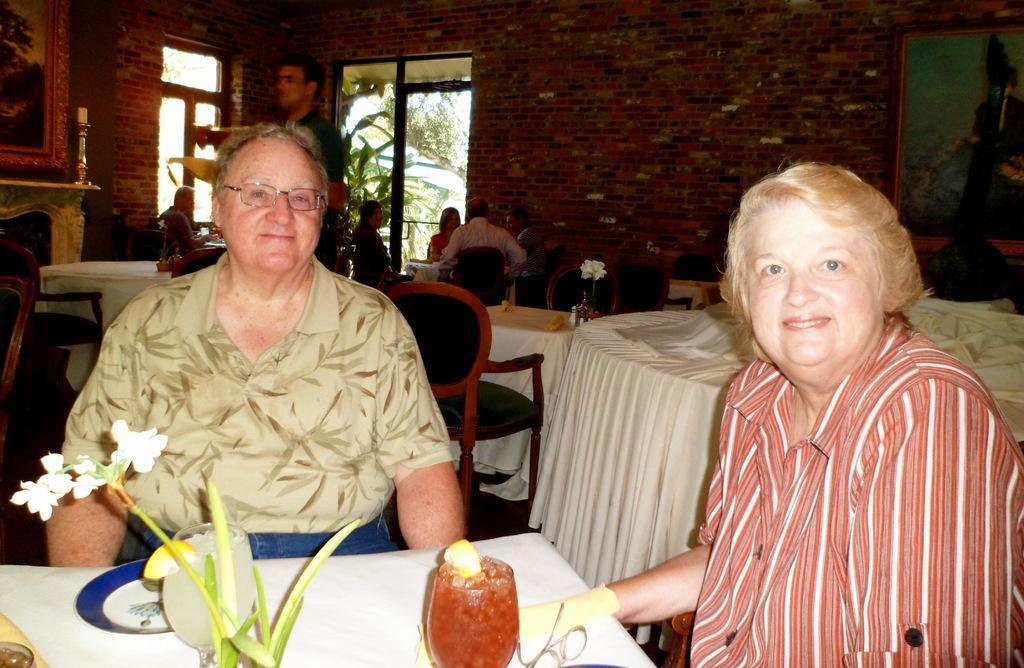Could you give a brief overview of what you see in this image? In this picture we can see group of people, few are seated on the chairs and a man is standing, in front of them we can see few glasses, flower vases and other things on the tables, behind them we can see few frames on the walls, in the background we can find few trees. 